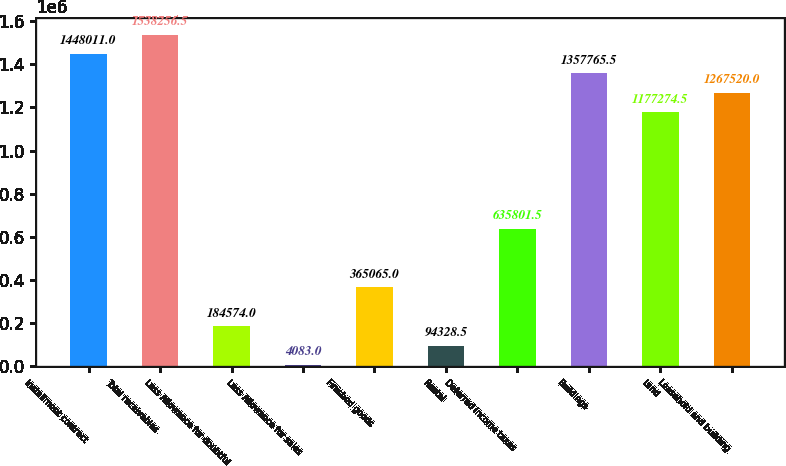Convert chart. <chart><loc_0><loc_0><loc_500><loc_500><bar_chart><fcel>Installment contract<fcel>Total receivables<fcel>Less Allowance for doubtful<fcel>Less Allowance for sales<fcel>Finished goods<fcel>Rental<fcel>Deferred income taxes<fcel>Buildings<fcel>Land<fcel>Leasehold and building<nl><fcel>1.44801e+06<fcel>1.53826e+06<fcel>184574<fcel>4083<fcel>365065<fcel>94328.5<fcel>635802<fcel>1.35777e+06<fcel>1.17727e+06<fcel>1.26752e+06<nl></chart> 